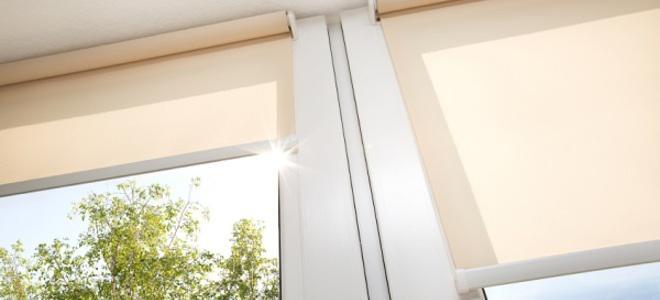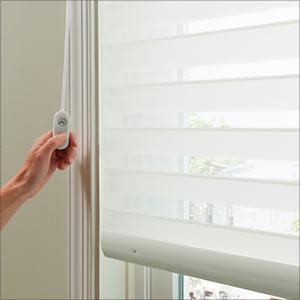The first image is the image on the left, the second image is the image on the right. Assess this claim about the two images: "There are no more than three blinds.". Correct or not? Answer yes or no. Yes. The first image is the image on the left, the second image is the image on the right. For the images shown, is this caption "There are exactly two window shades in the left image." true? Answer yes or no. Yes. 